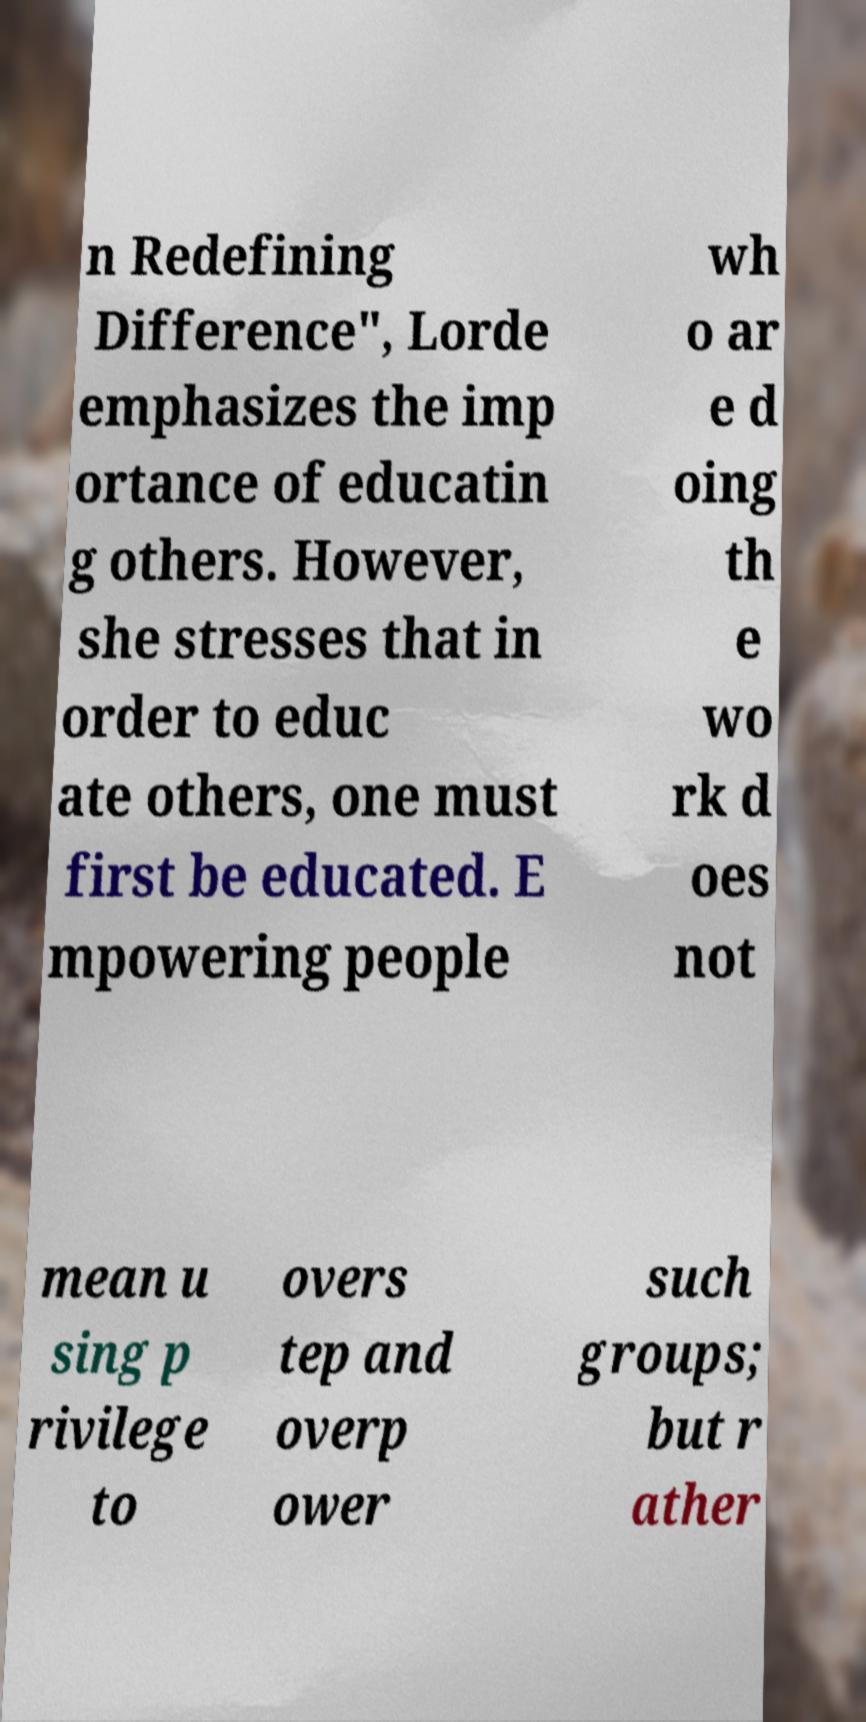What messages or text are displayed in this image? I need them in a readable, typed format. n Redefining Difference", Lorde emphasizes the imp ortance of educatin g others. However, she stresses that in order to educ ate others, one must first be educated. E mpowering people wh o ar e d oing th e wo rk d oes not mean u sing p rivilege to overs tep and overp ower such groups; but r ather 